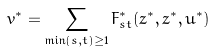<formula> <loc_0><loc_0><loc_500><loc_500>v ^ { * } = \sum _ { \min ( s , t ) \geq 1 } F _ { s t } ^ { * } ( z ^ { * } , \bar { z } ^ { * } , u ^ { * } )</formula> 